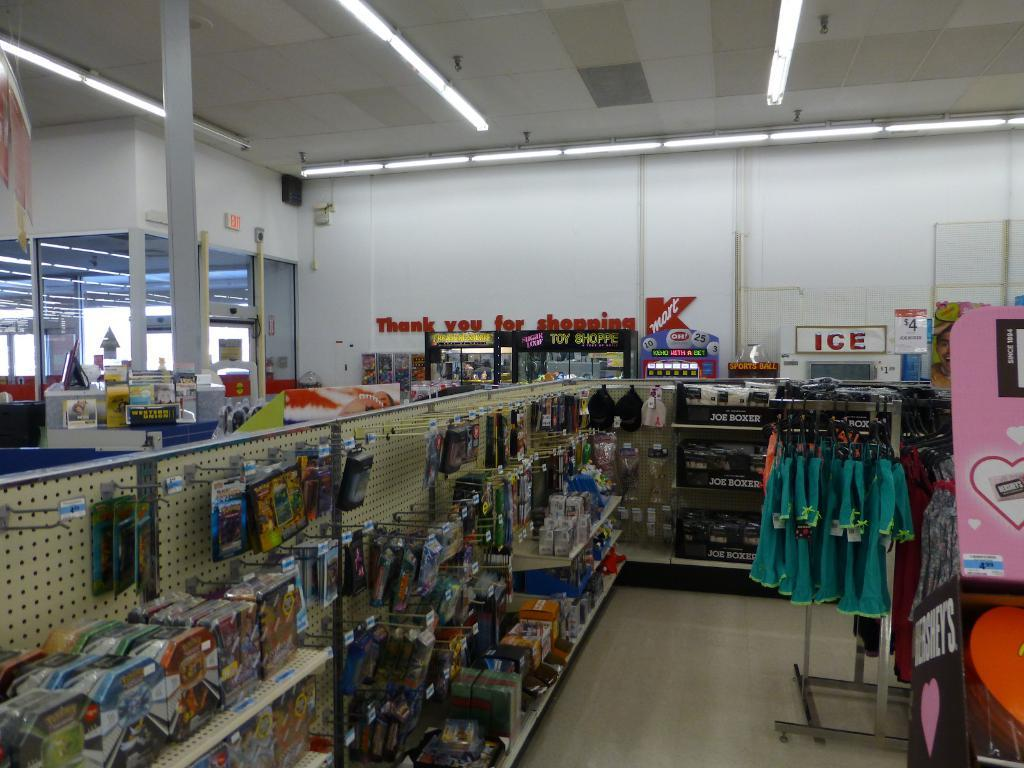<image>
Provide a brief description of the given image. A display of goods for sale in Kmart 